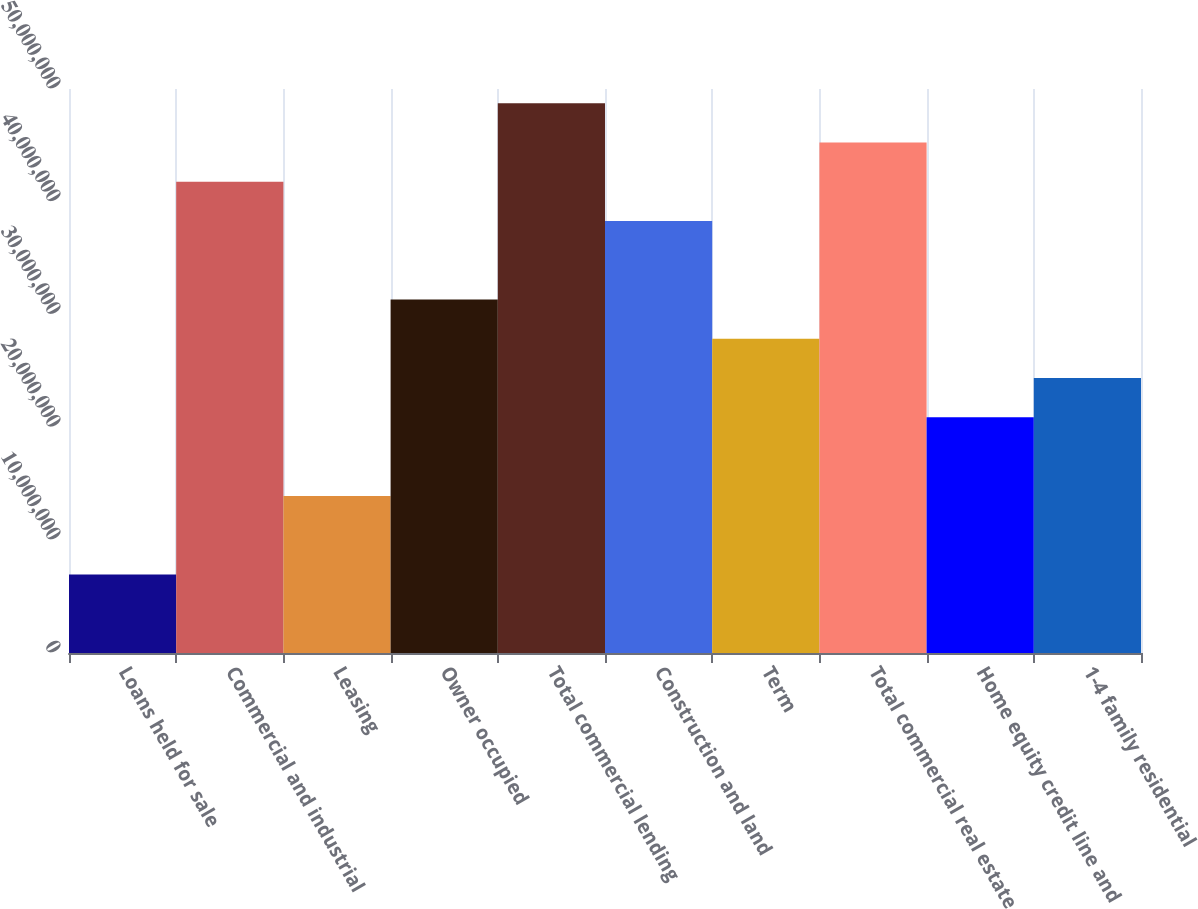Convert chart to OTSL. <chart><loc_0><loc_0><loc_500><loc_500><bar_chart><fcel>Loans held for sale<fcel>Commercial and industrial<fcel>Leasing<fcel>Owner occupied<fcel>Total commercial lending<fcel>Construction and land<fcel>Term<fcel>Total commercial real estate<fcel>Home equity credit line and<fcel>1-4 family residential<nl><fcel>6.96604e+06<fcel>4.17822e+07<fcel>1.39293e+07<fcel>3.13373e+07<fcel>4.87454e+07<fcel>3.83005e+07<fcel>2.78557e+07<fcel>4.52638e+07<fcel>2.08925e+07<fcel>2.43741e+07<nl></chart> 